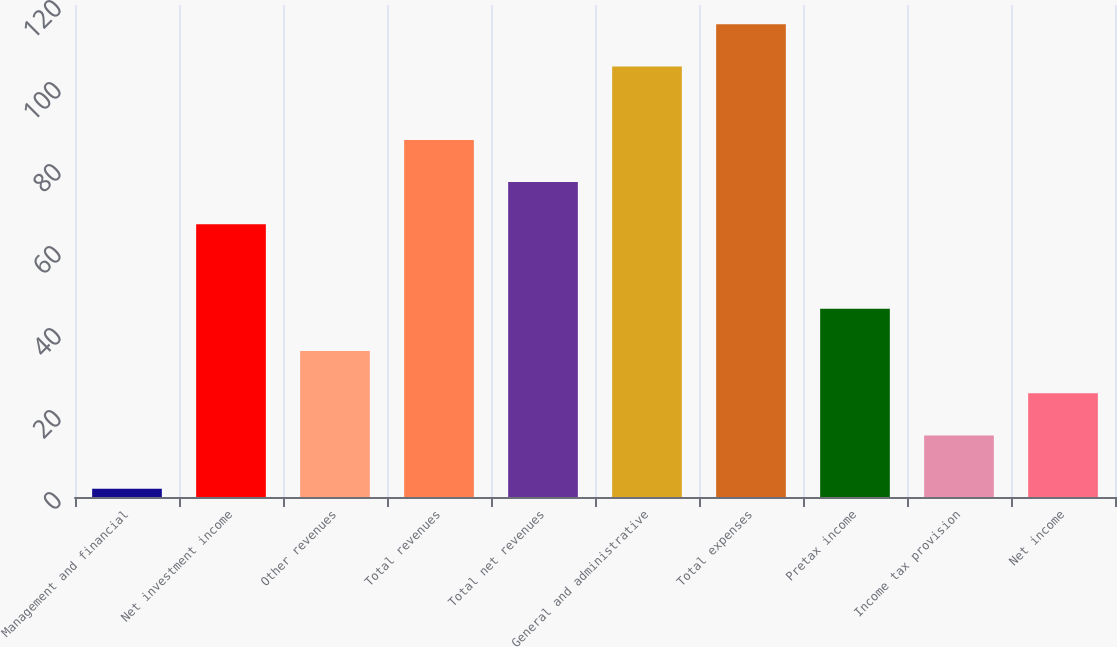<chart> <loc_0><loc_0><loc_500><loc_500><bar_chart><fcel>Management and financial<fcel>Net investment income<fcel>Other revenues<fcel>Total revenues<fcel>Total net revenues<fcel>General and administrative<fcel>Total expenses<fcel>Pretax income<fcel>Income tax provision<fcel>Net income<nl><fcel>2<fcel>66.5<fcel>35.6<fcel>87.1<fcel>76.8<fcel>105<fcel>115.3<fcel>45.9<fcel>15<fcel>25.3<nl></chart> 